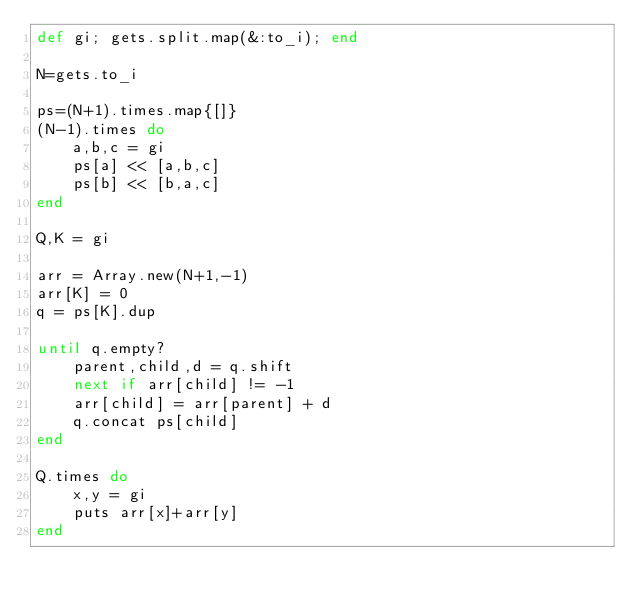Convert code to text. <code><loc_0><loc_0><loc_500><loc_500><_Ruby_>def gi; gets.split.map(&:to_i); end

N=gets.to_i

ps=(N+1).times.map{[]}
(N-1).times do
    a,b,c = gi
    ps[a] << [a,b,c]
    ps[b] << [b,a,c]
end

Q,K = gi

arr = Array.new(N+1,-1)
arr[K] = 0
q = ps[K].dup

until q.empty?
    parent,child,d = q.shift
    next if arr[child] != -1
    arr[child] = arr[parent] + d
    q.concat ps[child]
end

Q.times do
    x,y = gi
    puts arr[x]+arr[y]
end</code> 